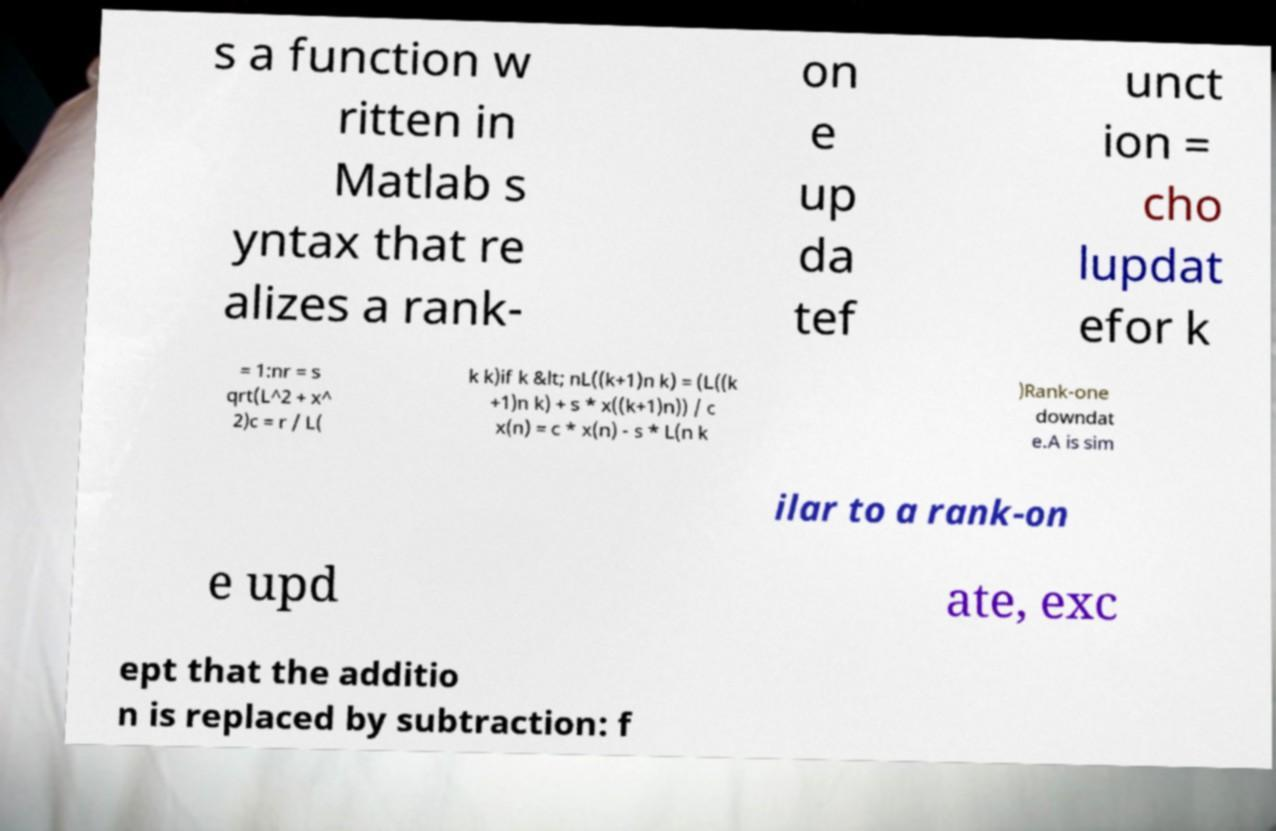Could you assist in decoding the text presented in this image and type it out clearly? s a function w ritten in Matlab s yntax that re alizes a rank- on e up da tef unct ion = cho lupdat efor k = 1:nr = s qrt(L^2 + x^ 2)c = r / L( k k)if k &lt; nL((k+1)n k) = (L((k +1)n k) + s * x((k+1)n)) / c x(n) = c * x(n) - s * L(n k )Rank-one downdat e.A is sim ilar to a rank-on e upd ate, exc ept that the additio n is replaced by subtraction: f 